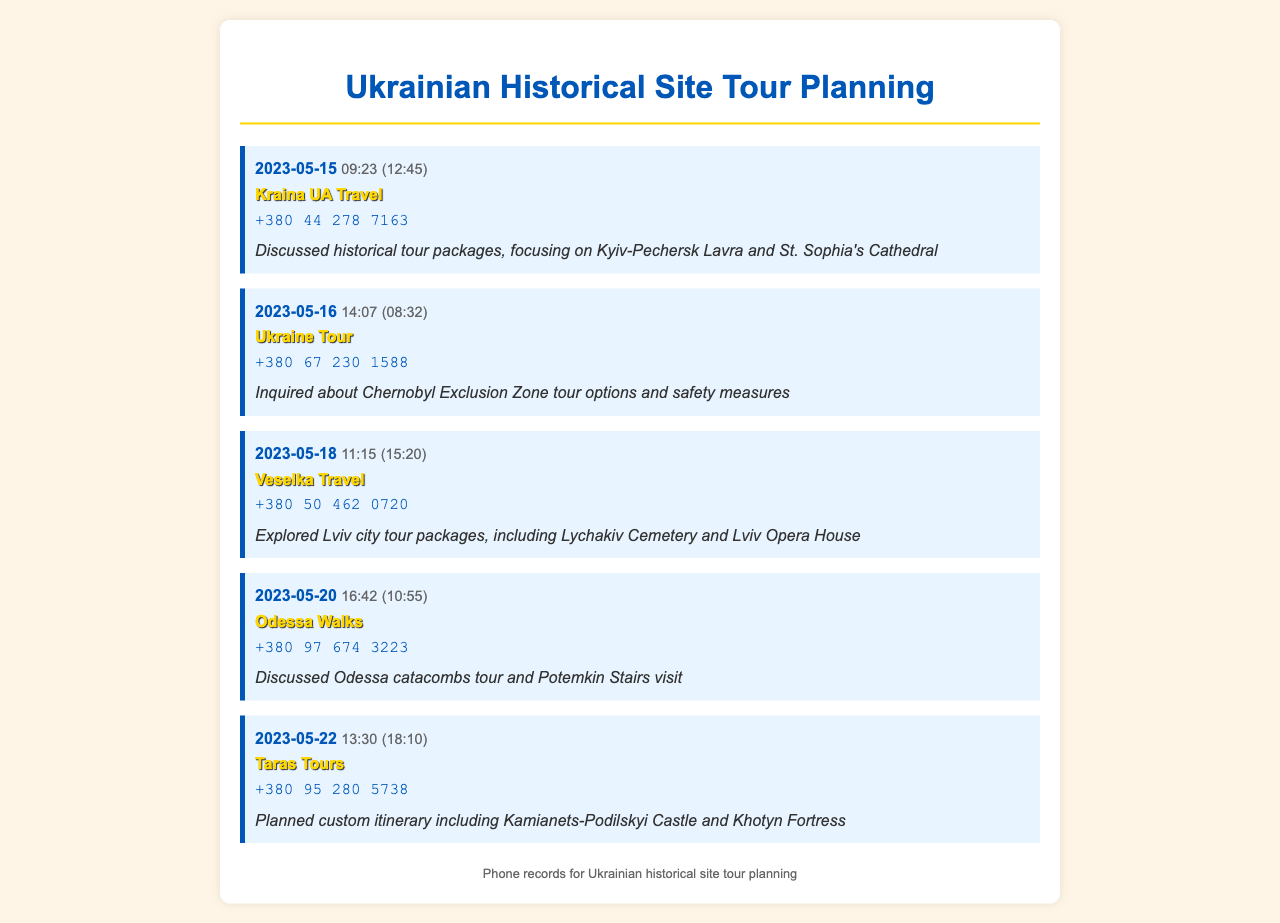what is the date of the first call? The first call is recorded on May 15, 2023.
Answer: May 15, 2023 who did you call on May 18? The call on May 18 was made to Veselka Travel.
Answer: Veselka Travel how long was the call with Kraina UA Travel? The duration of the call with Kraina UA Travel was 12 minutes and 45 seconds.
Answer: 12:45 what historical site was discussed in the call with Ukraine Tour? The call with Ukraine Tour discussed the Chernobyl Exclusion Zone tour options.
Answer: Chernobyl Exclusion Zone which travel agency offered a custom itinerary? The agency that offered a custom itinerary is Taras Tours.
Answer: Taras Tours what time did the call with Odessa Walks take place? The call with Odessa Walks occurred at 16:42.
Answer: 16:42 how many calls were made in total? The document lists a total of five outgoing calls.
Answer: 5 which travel agency focuses on Lviv city tours? Veselka Travel focuses on Lviv city tours.
Answer: Veselka Travel 